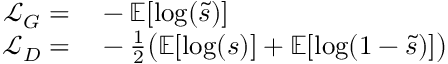Convert formula to latex. <formula><loc_0><loc_0><loc_500><loc_500>\begin{array} { r l } { \mathcal { L } _ { G } = } & - \mathbb { E } [ \log ( \tilde { s } ) ] } \\ { \mathcal { L } _ { D } = } & - \frac { 1 } { 2 } \left ( \mathbb { E } [ \log ( s ) ] + \mathbb { E } [ \log ( 1 - \tilde { s } ) ] \right ) } \end{array}</formula> 